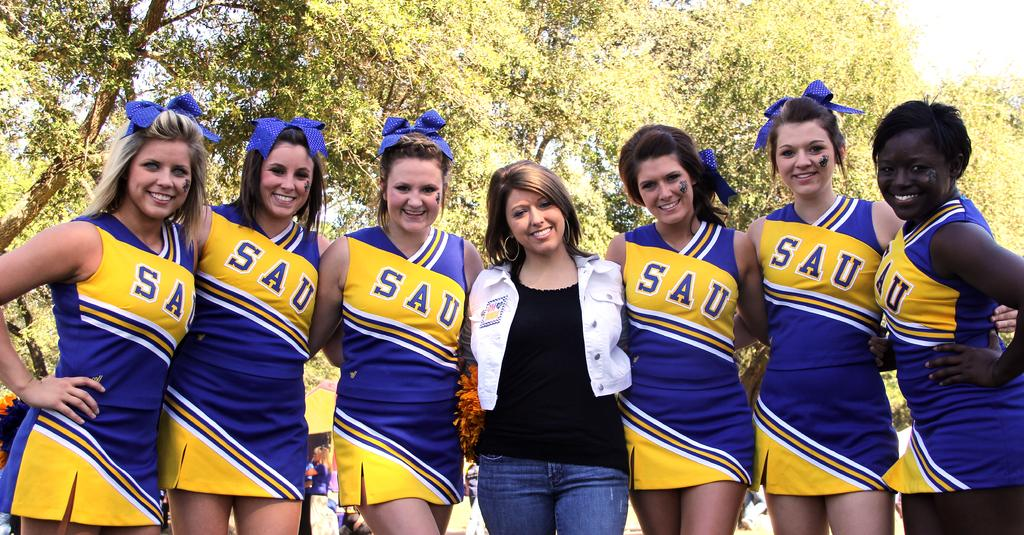Provide a one-sentence caption for the provided image. A group of cheerleaders with SAU on the front. 